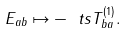Convert formula to latex. <formula><loc_0><loc_0><loc_500><loc_500>E _ { a b } \mapsto - \ t s T _ { b a } ^ { ( 1 ) } .</formula> 